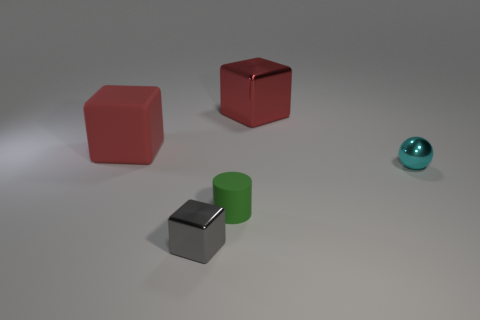What number of tiny things are either green metallic cylinders or red blocks?
Offer a terse response. 0. There is a large cube that is the same color as the large rubber thing; what is its material?
Make the answer very short. Metal. Does the red cube that is left of the big red shiny cube have the same material as the thing to the right of the red metal object?
Your response must be concise. No. Are there any things?
Your answer should be compact. Yes. Is the number of big blocks that are right of the small gray metallic object greater than the number of red objects to the right of the tiny cyan object?
Your answer should be compact. Yes. What material is the gray object that is the same shape as the big red rubber object?
Provide a succinct answer. Metal. There is a rubber object behind the cyan metallic sphere; is it the same color as the big block that is right of the tiny green rubber thing?
Provide a succinct answer. Yes. What is the shape of the small green thing?
Your response must be concise. Cylinder. Is the number of shiny blocks that are left of the tiny rubber cylinder greater than the number of red metal cubes?
Offer a very short reply. No. What is the shape of the rubber object that is behind the small ball?
Ensure brevity in your answer.  Cube. 